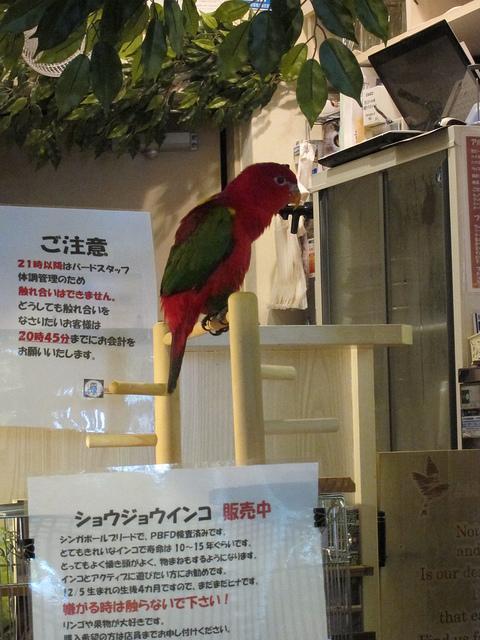How many airplanes have a vehicle under their wing?
Give a very brief answer. 0. 